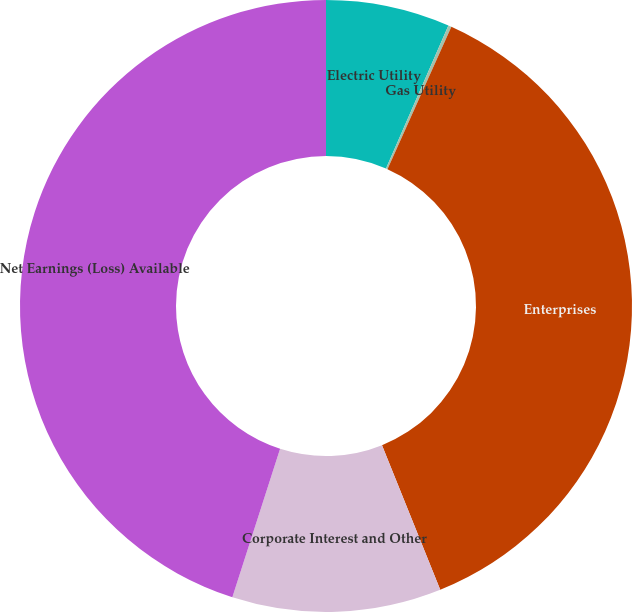<chart> <loc_0><loc_0><loc_500><loc_500><pie_chart><fcel>Electric Utility<fcel>Gas Utility<fcel>Enterprises<fcel>Corporate Interest and Other<fcel>Net Earnings (Loss) Available<nl><fcel>6.55%<fcel>0.17%<fcel>37.19%<fcel>11.04%<fcel>45.05%<nl></chart> 